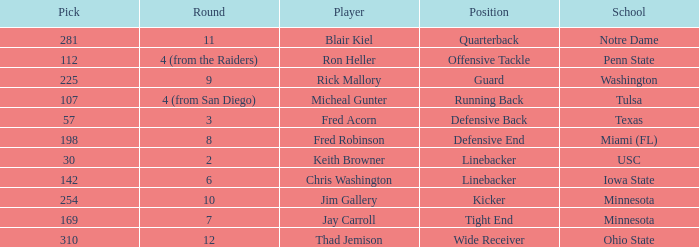What is the pick number of Penn State? 112.0. Can you parse all the data within this table? {'header': ['Pick', 'Round', 'Player', 'Position', 'School'], 'rows': [['281', '11', 'Blair Kiel', 'Quarterback', 'Notre Dame'], ['112', '4 (from the Raiders)', 'Ron Heller', 'Offensive Tackle', 'Penn State'], ['225', '9', 'Rick Mallory', 'Guard', 'Washington'], ['107', '4 (from San Diego)', 'Micheal Gunter', 'Running Back', 'Tulsa'], ['57', '3', 'Fred Acorn', 'Defensive Back', 'Texas'], ['198', '8', 'Fred Robinson', 'Defensive End', 'Miami (FL)'], ['30', '2', 'Keith Browner', 'Linebacker', 'USC'], ['142', '6', 'Chris Washington', 'Linebacker', 'Iowa State'], ['254', '10', 'Jim Gallery', 'Kicker', 'Minnesota'], ['169', '7', 'Jay Carroll', 'Tight End', 'Minnesota'], ['310', '12', 'Thad Jemison', 'Wide Receiver', 'Ohio State']]} 